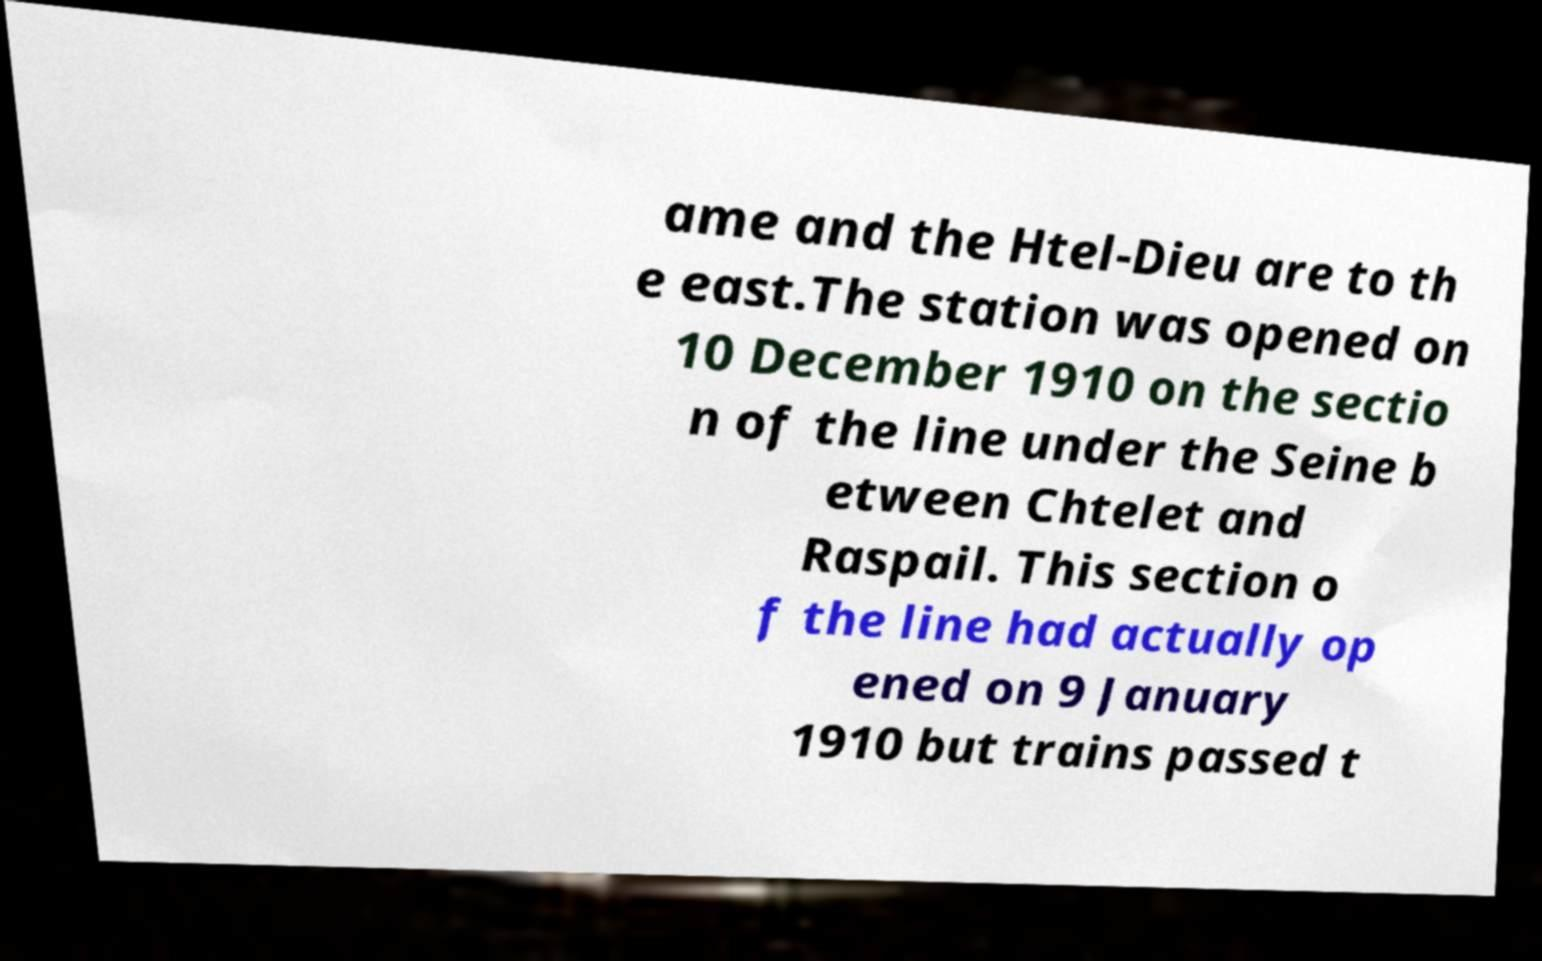Can you accurately transcribe the text from the provided image for me? ame and the Htel-Dieu are to th e east.The station was opened on 10 December 1910 on the sectio n of the line under the Seine b etween Chtelet and Raspail. This section o f the line had actually op ened on 9 January 1910 but trains passed t 